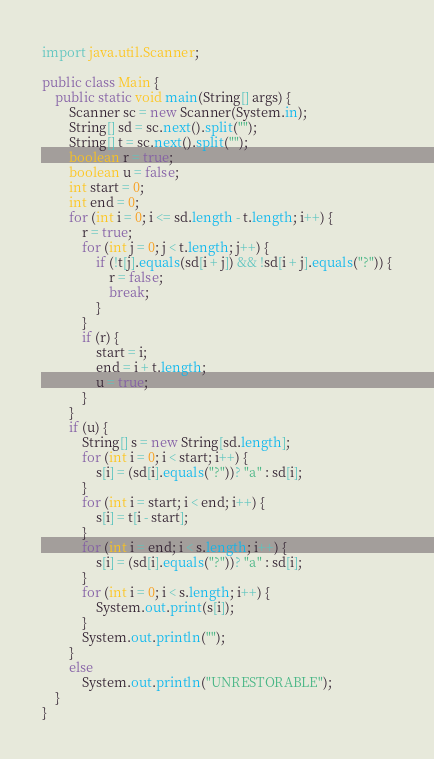Convert code to text. <code><loc_0><loc_0><loc_500><loc_500><_Java_>import java.util.Scanner;

public class Main {
	public static void main(String[] args) {
		Scanner sc = new Scanner(System.in);
		String[] sd = sc.next().split("");
		String[] t = sc.next().split("");
		boolean r = true;
		boolean u = false;
		int start = 0;
		int end = 0;
		for (int i = 0; i <= sd.length - t.length; i++) {
			r = true;
			for (int j = 0; j < t.length; j++) {
				if (!t[j].equals(sd[i + j]) && !sd[i + j].equals("?")) {
					r = false;
					break;
				}
			}
			if (r) {
				start = i;
				end = i + t.length;
				u = true;
			}
		}
		if (u) {
			String[] s = new String[sd.length];
			for (int i = 0; i < start; i++) {
				s[i] = (sd[i].equals("?"))? "a" : sd[i];
			}
			for (int i = start; i < end; i++) {
				s[i] = t[i - start];
			}
			for (int i = end; i < s.length; i++) {
				s[i] = (sd[i].equals("?"))? "a" : sd[i];
			}
			for (int i = 0; i < s.length; i++) {
				System.out.print(s[i]);
			}
			System.out.println("");
		}
		else
			System.out.println("UNRESTORABLE");
	}
}</code> 